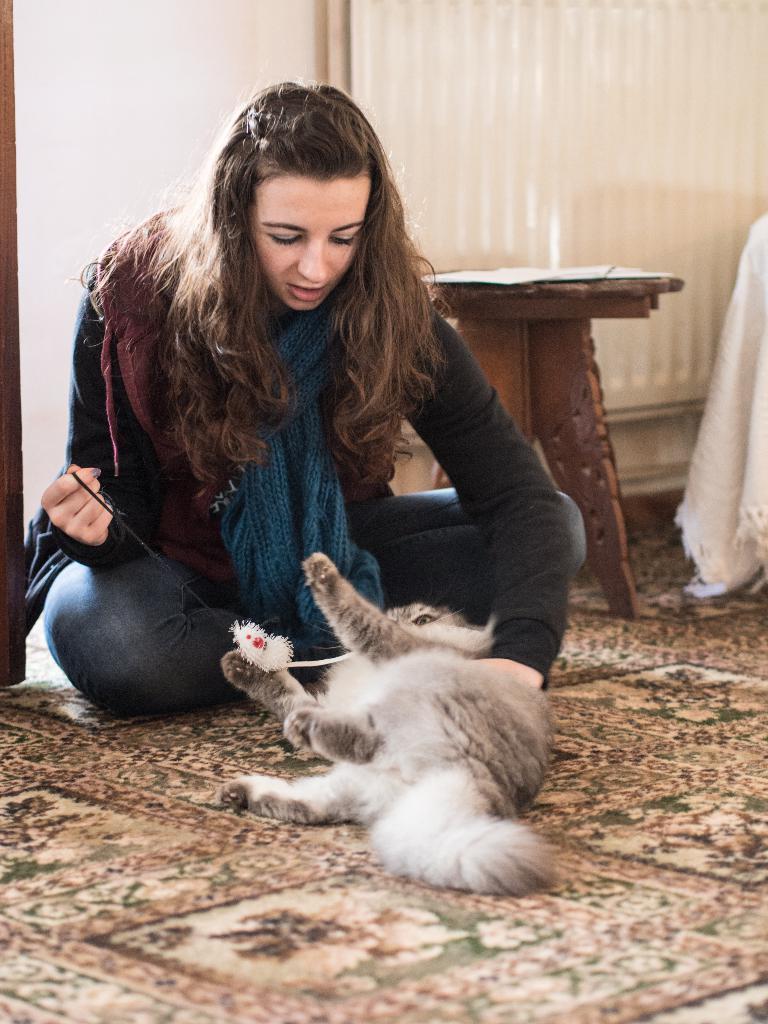Can you describe this image briefly? In the center we can see one woman she is holding one cat. Coming to the background there is a curtain. 